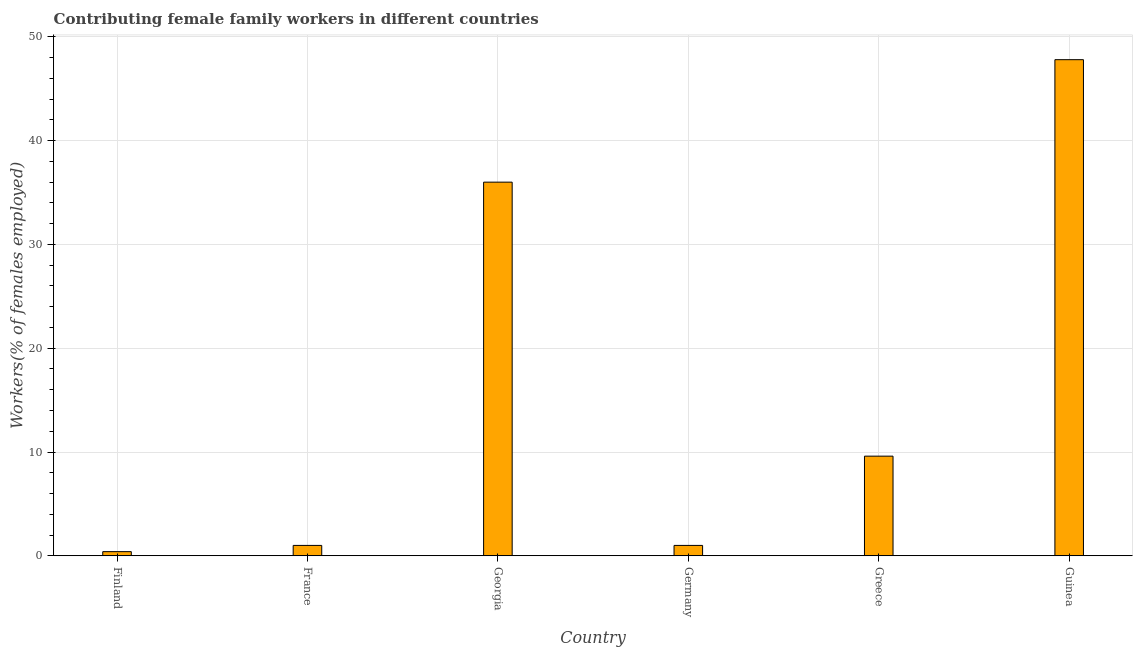Does the graph contain grids?
Give a very brief answer. Yes. What is the title of the graph?
Provide a short and direct response. Contributing female family workers in different countries. What is the label or title of the X-axis?
Make the answer very short. Country. What is the label or title of the Y-axis?
Make the answer very short. Workers(% of females employed). What is the contributing female family workers in Guinea?
Your answer should be very brief. 47.8. Across all countries, what is the maximum contributing female family workers?
Give a very brief answer. 47.8. Across all countries, what is the minimum contributing female family workers?
Provide a short and direct response. 0.4. In which country was the contributing female family workers maximum?
Provide a succinct answer. Guinea. In which country was the contributing female family workers minimum?
Your answer should be very brief. Finland. What is the sum of the contributing female family workers?
Your answer should be very brief. 95.8. What is the difference between the contributing female family workers in France and Georgia?
Your answer should be compact. -35. What is the average contributing female family workers per country?
Provide a short and direct response. 15.97. What is the median contributing female family workers?
Keep it short and to the point. 5.3. In how many countries, is the contributing female family workers greater than 20 %?
Your answer should be compact. 2. What is the ratio of the contributing female family workers in France to that in Georgia?
Give a very brief answer. 0.03. Is the contributing female family workers in Finland less than that in Georgia?
Provide a short and direct response. Yes. Is the difference between the contributing female family workers in Georgia and Germany greater than the difference between any two countries?
Give a very brief answer. No. What is the difference between the highest and the second highest contributing female family workers?
Your answer should be compact. 11.8. Is the sum of the contributing female family workers in Finland and France greater than the maximum contributing female family workers across all countries?
Your response must be concise. No. What is the difference between the highest and the lowest contributing female family workers?
Your answer should be compact. 47.4. In how many countries, is the contributing female family workers greater than the average contributing female family workers taken over all countries?
Keep it short and to the point. 2. How many bars are there?
Ensure brevity in your answer.  6. Are all the bars in the graph horizontal?
Provide a short and direct response. No. How many countries are there in the graph?
Your response must be concise. 6. Are the values on the major ticks of Y-axis written in scientific E-notation?
Keep it short and to the point. No. What is the Workers(% of females employed) in Finland?
Your response must be concise. 0.4. What is the Workers(% of females employed) of France?
Your response must be concise. 1. What is the Workers(% of females employed) in Georgia?
Your answer should be compact. 36. What is the Workers(% of females employed) in Greece?
Provide a short and direct response. 9.6. What is the Workers(% of females employed) of Guinea?
Ensure brevity in your answer.  47.8. What is the difference between the Workers(% of females employed) in Finland and France?
Provide a short and direct response. -0.6. What is the difference between the Workers(% of females employed) in Finland and Georgia?
Your response must be concise. -35.6. What is the difference between the Workers(% of females employed) in Finland and Guinea?
Keep it short and to the point. -47.4. What is the difference between the Workers(% of females employed) in France and Georgia?
Your response must be concise. -35. What is the difference between the Workers(% of females employed) in France and Germany?
Offer a terse response. 0. What is the difference between the Workers(% of females employed) in France and Guinea?
Provide a succinct answer. -46.8. What is the difference between the Workers(% of females employed) in Georgia and Germany?
Keep it short and to the point. 35. What is the difference between the Workers(% of females employed) in Georgia and Greece?
Ensure brevity in your answer.  26.4. What is the difference between the Workers(% of females employed) in Germany and Guinea?
Offer a terse response. -46.8. What is the difference between the Workers(% of females employed) in Greece and Guinea?
Your response must be concise. -38.2. What is the ratio of the Workers(% of females employed) in Finland to that in France?
Provide a succinct answer. 0.4. What is the ratio of the Workers(% of females employed) in Finland to that in Georgia?
Provide a succinct answer. 0.01. What is the ratio of the Workers(% of females employed) in Finland to that in Germany?
Give a very brief answer. 0.4. What is the ratio of the Workers(% of females employed) in Finland to that in Greece?
Provide a short and direct response. 0.04. What is the ratio of the Workers(% of females employed) in Finland to that in Guinea?
Provide a succinct answer. 0.01. What is the ratio of the Workers(% of females employed) in France to that in Georgia?
Keep it short and to the point. 0.03. What is the ratio of the Workers(% of females employed) in France to that in Germany?
Ensure brevity in your answer.  1. What is the ratio of the Workers(% of females employed) in France to that in Greece?
Your response must be concise. 0.1. What is the ratio of the Workers(% of females employed) in France to that in Guinea?
Offer a terse response. 0.02. What is the ratio of the Workers(% of females employed) in Georgia to that in Greece?
Offer a very short reply. 3.75. What is the ratio of the Workers(% of females employed) in Georgia to that in Guinea?
Your response must be concise. 0.75. What is the ratio of the Workers(% of females employed) in Germany to that in Greece?
Your answer should be compact. 0.1. What is the ratio of the Workers(% of females employed) in Germany to that in Guinea?
Your answer should be compact. 0.02. What is the ratio of the Workers(% of females employed) in Greece to that in Guinea?
Provide a short and direct response. 0.2. 